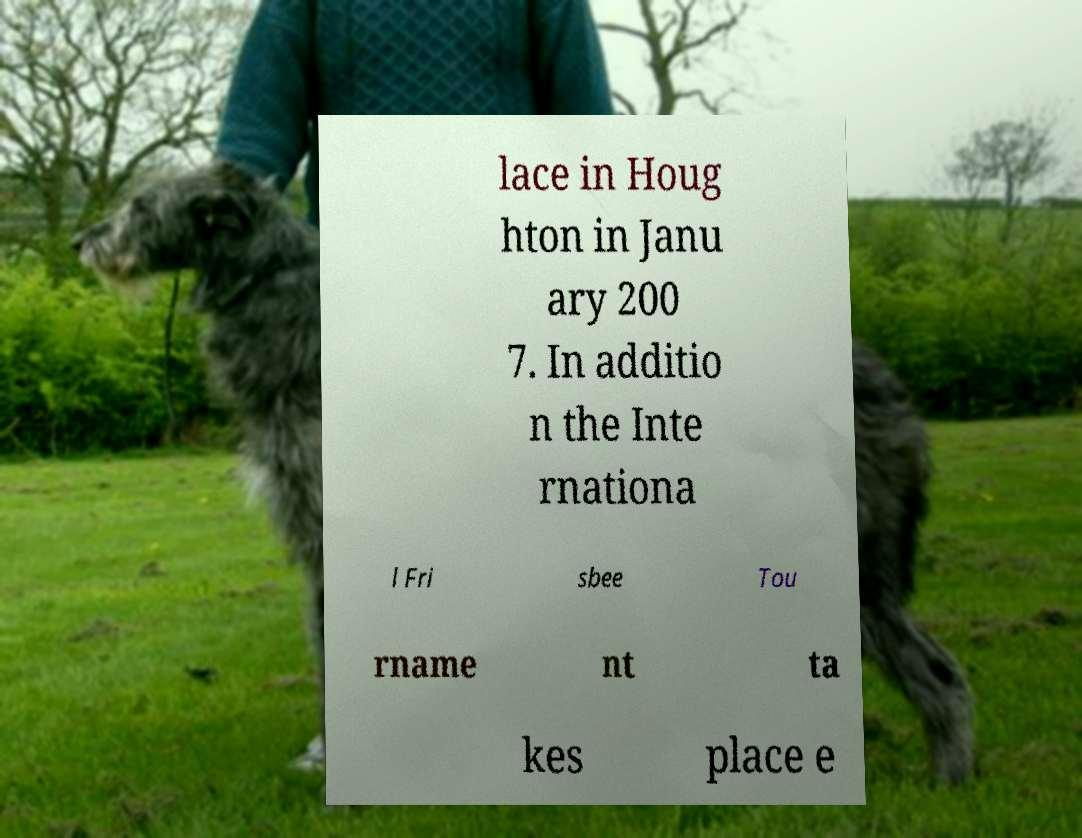What messages or text are displayed in this image? I need them in a readable, typed format. lace in Houg hton in Janu ary 200 7. In additio n the Inte rnationa l Fri sbee Tou rname nt ta kes place e 